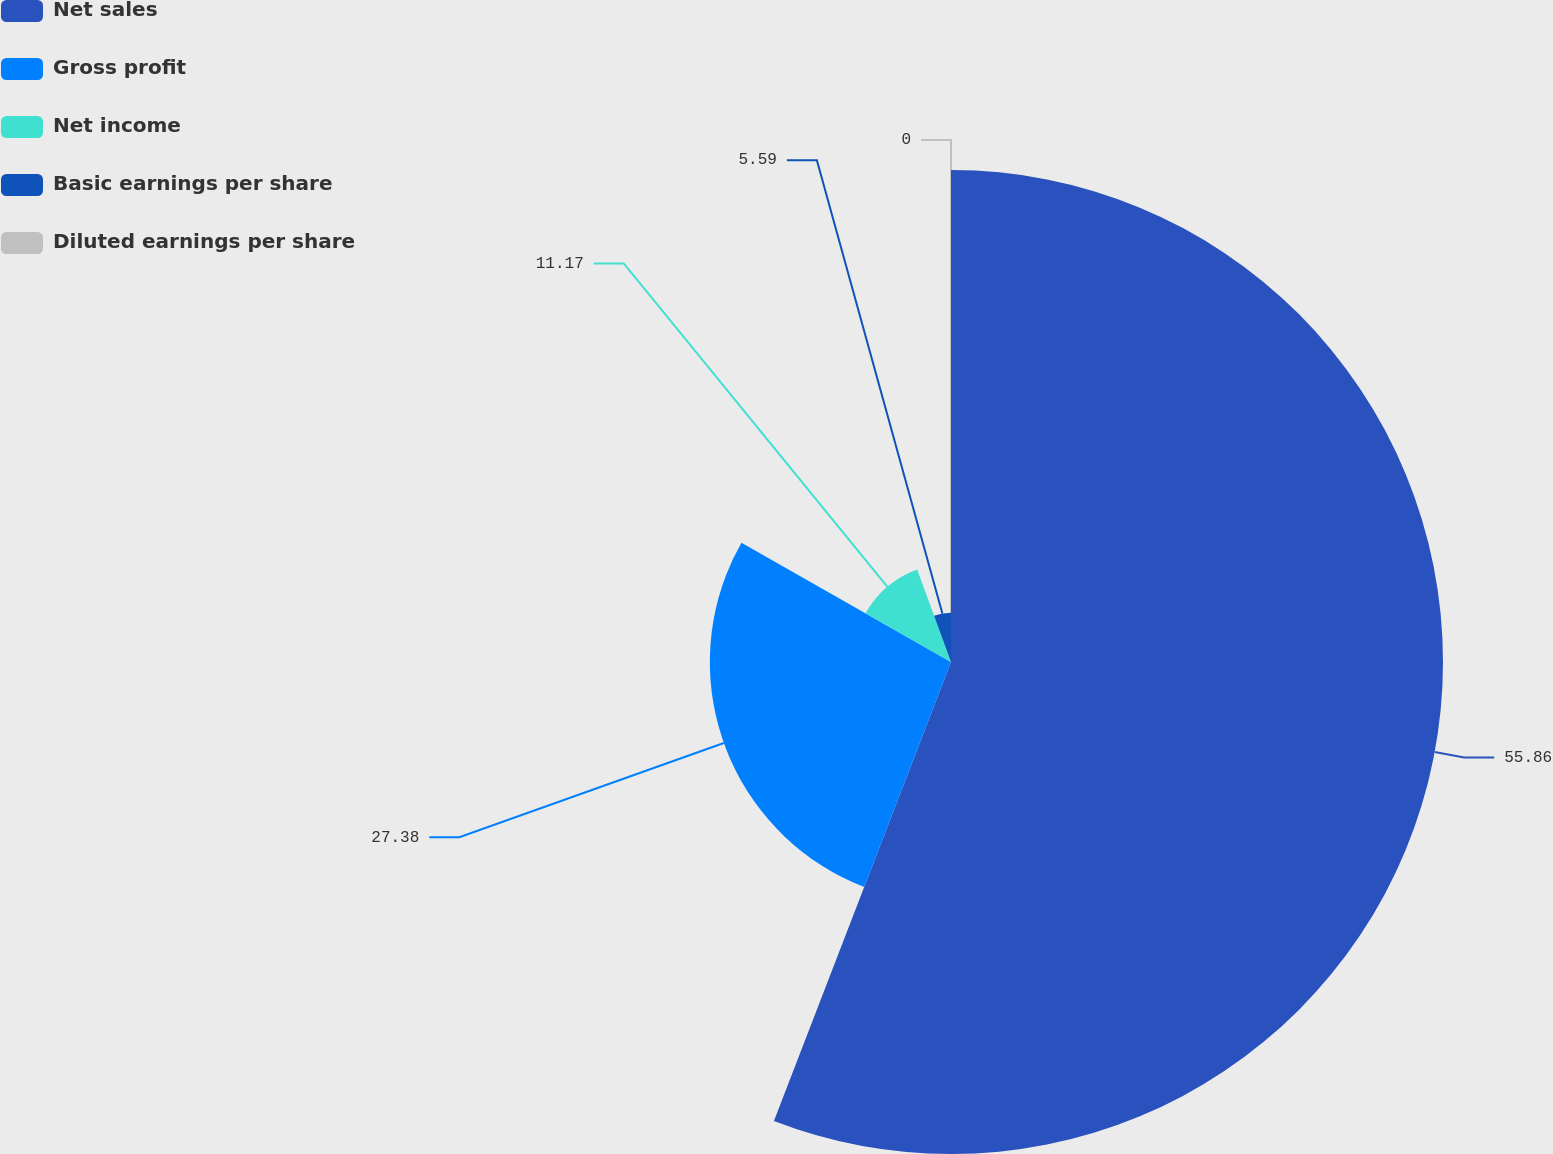Convert chart to OTSL. <chart><loc_0><loc_0><loc_500><loc_500><pie_chart><fcel>Net sales<fcel>Gross profit<fcel>Net income<fcel>Basic earnings per share<fcel>Diluted earnings per share<nl><fcel>55.86%<fcel>27.38%<fcel>11.17%<fcel>5.59%<fcel>0.0%<nl></chart> 